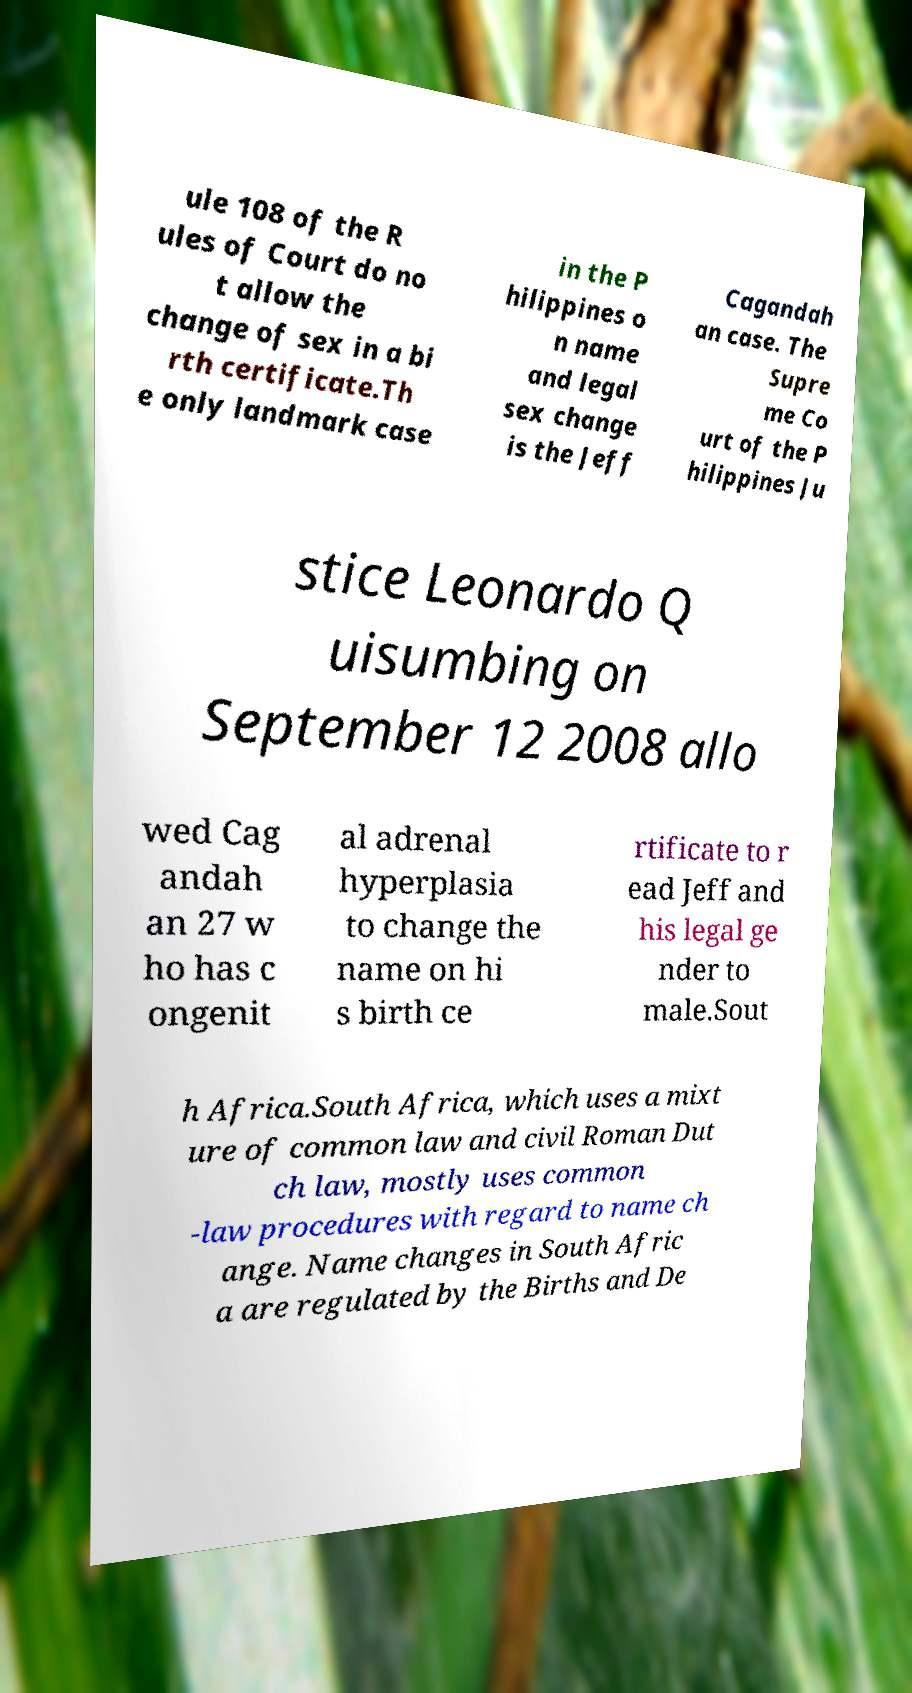There's text embedded in this image that I need extracted. Can you transcribe it verbatim? ule 108 of the R ules of Court do no t allow the change of sex in a bi rth certificate.Th e only landmark case in the P hilippines o n name and legal sex change is the Jeff Cagandah an case. The Supre me Co urt of the P hilippines Ju stice Leonardo Q uisumbing on September 12 2008 allo wed Cag andah an 27 w ho has c ongenit al adrenal hyperplasia to change the name on hi s birth ce rtificate to r ead Jeff and his legal ge nder to male.Sout h Africa.South Africa, which uses a mixt ure of common law and civil Roman Dut ch law, mostly uses common -law procedures with regard to name ch ange. Name changes in South Afric a are regulated by the Births and De 